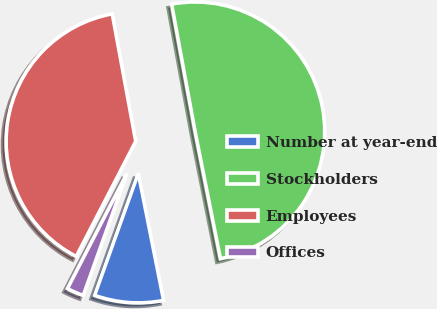Convert chart to OTSL. <chart><loc_0><loc_0><loc_500><loc_500><pie_chart><fcel>Number at year-end<fcel>Stockholders<fcel>Employees<fcel>Offices<nl><fcel>8.6%<fcel>49.77%<fcel>39.51%<fcel>2.12%<nl></chart> 